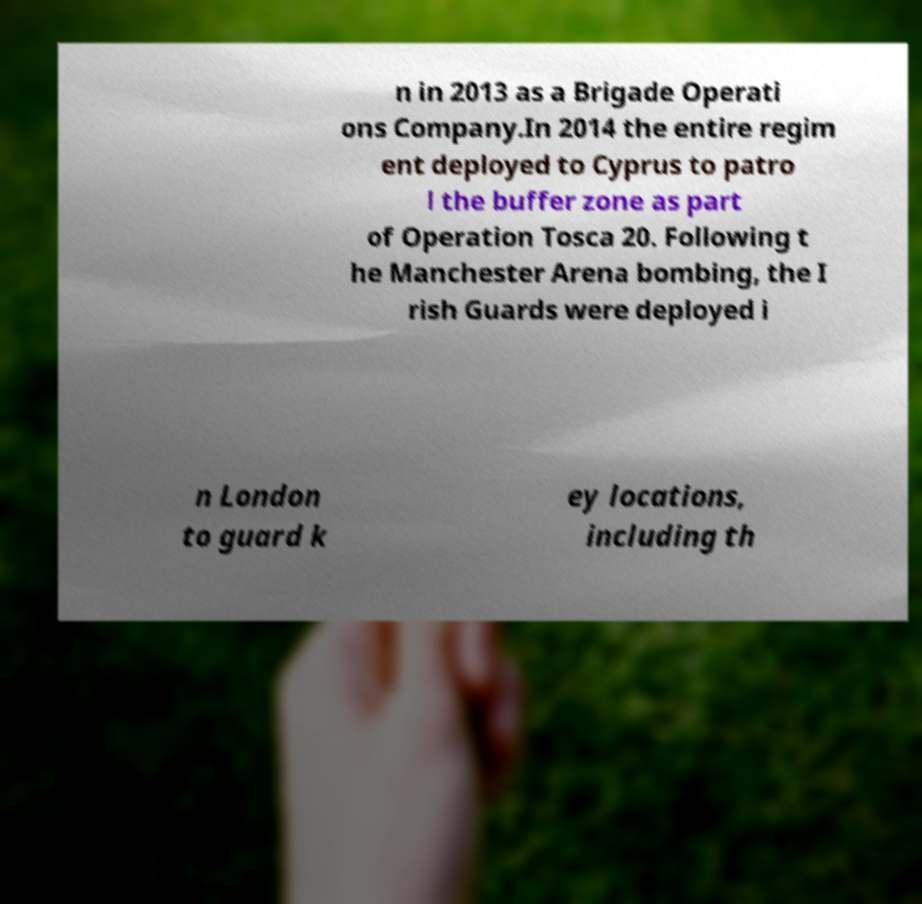Can you accurately transcribe the text from the provided image for me? n in 2013 as a Brigade Operati ons Company.In 2014 the entire regim ent deployed to Cyprus to patro l the buffer zone as part of Operation Tosca 20. Following t he Manchester Arena bombing, the I rish Guards were deployed i n London to guard k ey locations, including th 